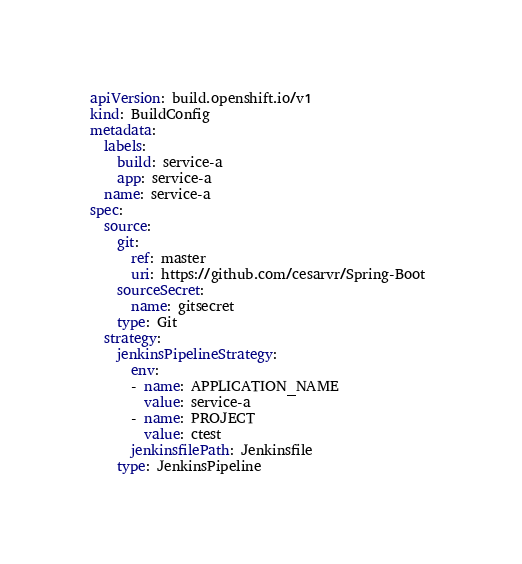<code> <loc_0><loc_0><loc_500><loc_500><_YAML_>apiVersion: build.openshift.io/v1
kind: BuildConfig
metadata:
  labels:
    build: service-a
    app: service-a
  name: service-a
spec:
  source:
    git:
      ref: master
      uri: https://github.com/cesarvr/Spring-Boot 
    sourceSecret:
      name: gitsecret
    type: Git
  strategy:
    jenkinsPipelineStrategy:
      env:
      - name: APPLICATION_NAME
        value: service-a 
      - name: PROJECT
        value: ctest
      jenkinsfilePath: Jenkinsfile
    type: JenkinsPipeline
</code> 